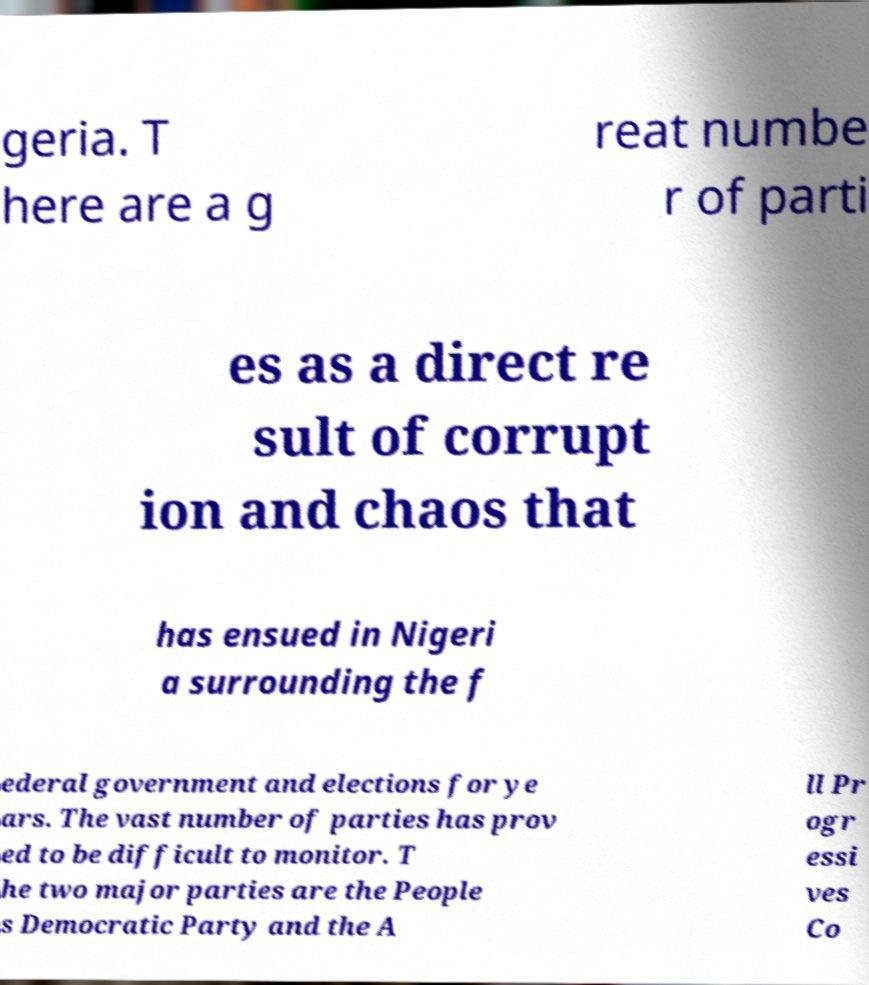Could you assist in decoding the text presented in this image and type it out clearly? geria. T here are a g reat numbe r of parti es as a direct re sult of corrupt ion and chaos that has ensued in Nigeri a surrounding the f ederal government and elections for ye ars. The vast number of parties has prov ed to be difficult to monitor. T he two major parties are the People s Democratic Party and the A ll Pr ogr essi ves Co 